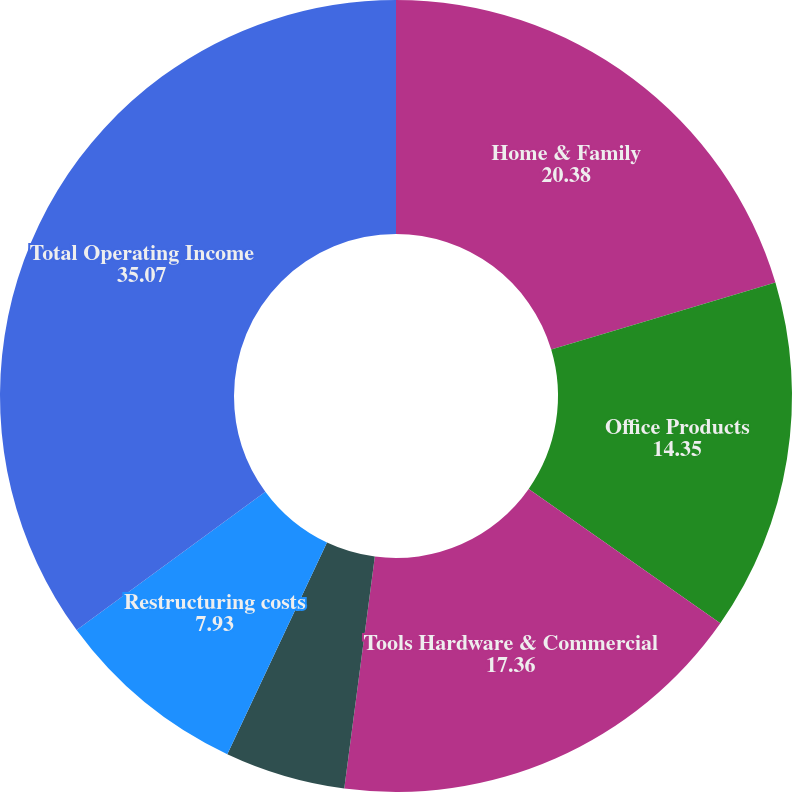Convert chart. <chart><loc_0><loc_0><loc_500><loc_500><pie_chart><fcel>Home & Family<fcel>Office Products<fcel>Tools Hardware & Commercial<fcel>Corporate<fcel>Restructuring costs<fcel>Total Operating Income<nl><fcel>20.38%<fcel>14.35%<fcel>17.36%<fcel>4.92%<fcel>7.93%<fcel>35.07%<nl></chart> 